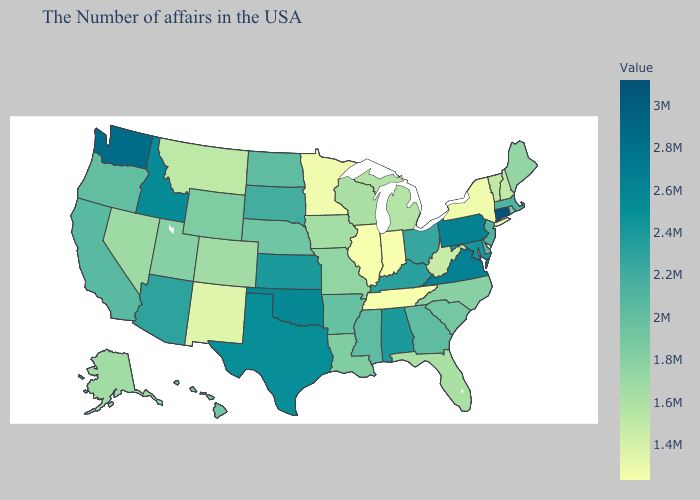Does Tennessee have a higher value than Delaware?
Quick response, please. No. Which states have the highest value in the USA?
Short answer required. Connecticut. Does Vermont have the lowest value in the USA?
Quick response, please. No. Which states have the highest value in the USA?
Give a very brief answer. Connecticut. Is the legend a continuous bar?
Short answer required. Yes. Which states hav the highest value in the Northeast?
Write a very short answer. Connecticut. 